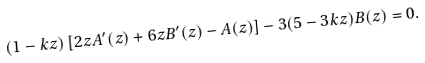Convert formula to latex. <formula><loc_0><loc_0><loc_500><loc_500>( 1 - k z ) \left [ 2 z A ^ { \prime } ( z ) + 6 z B ^ { \prime } ( z ) - A ( z ) \right ] - 3 ( 5 - 3 k z ) B ( z ) = 0 .</formula> 